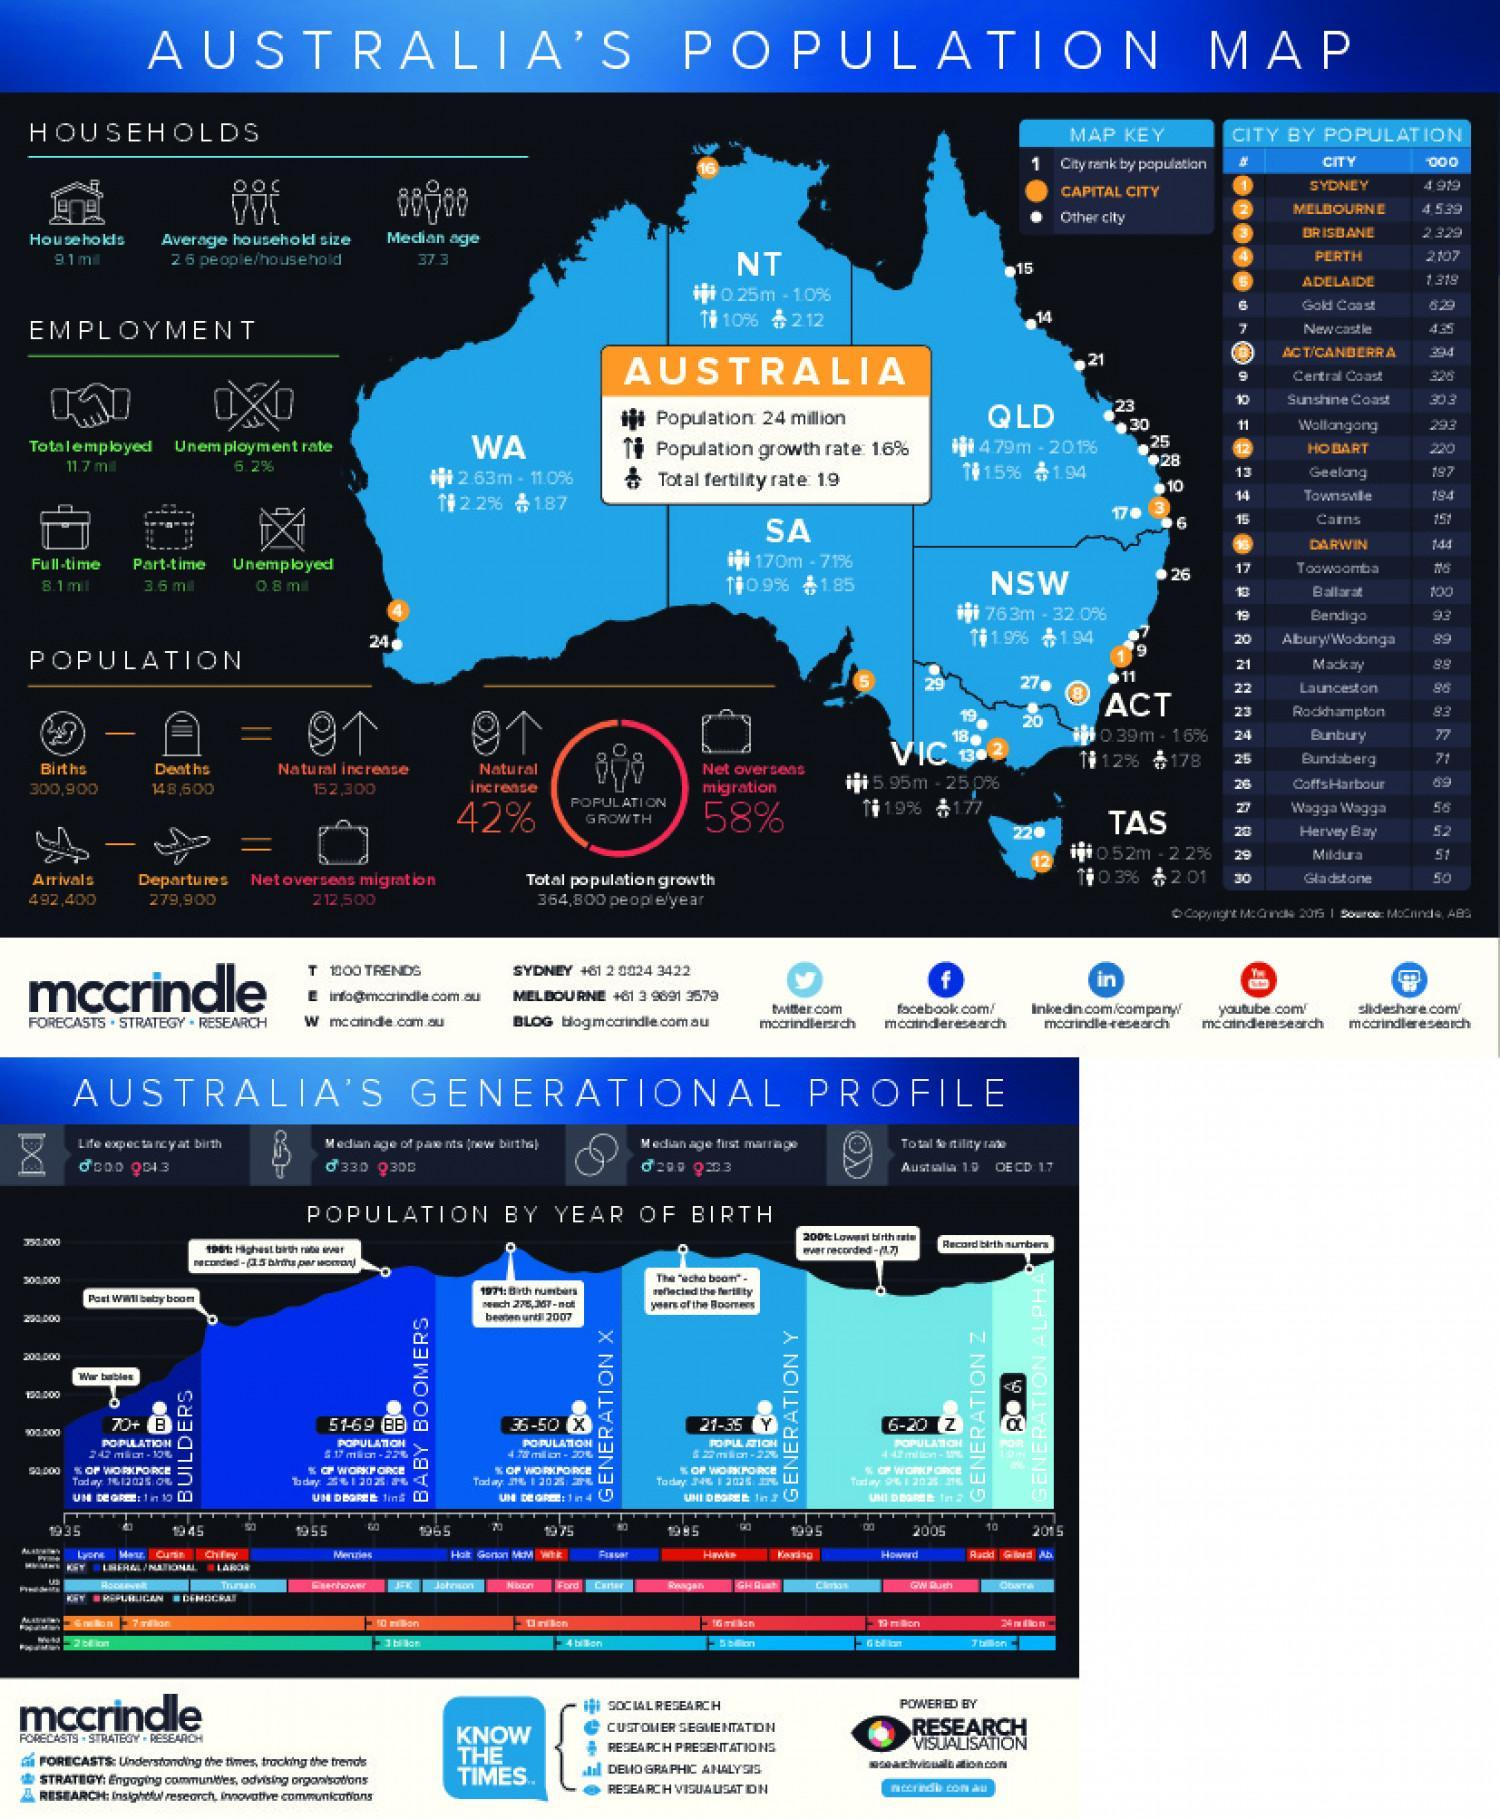Which is the capital city of Western Australia(WA)?
Answer the question with a short phrase. PERTH Which is the highest populated city in Australia? SYDNEY What is the net overseas migration rate in Australia? 58% What is the average household size in australia? 26 people/household What is the total fertility rate in Australia? 1.9 Which is the capital city of Tasmania(TAS)? HOBART What is the total population in Australia? 24 million 